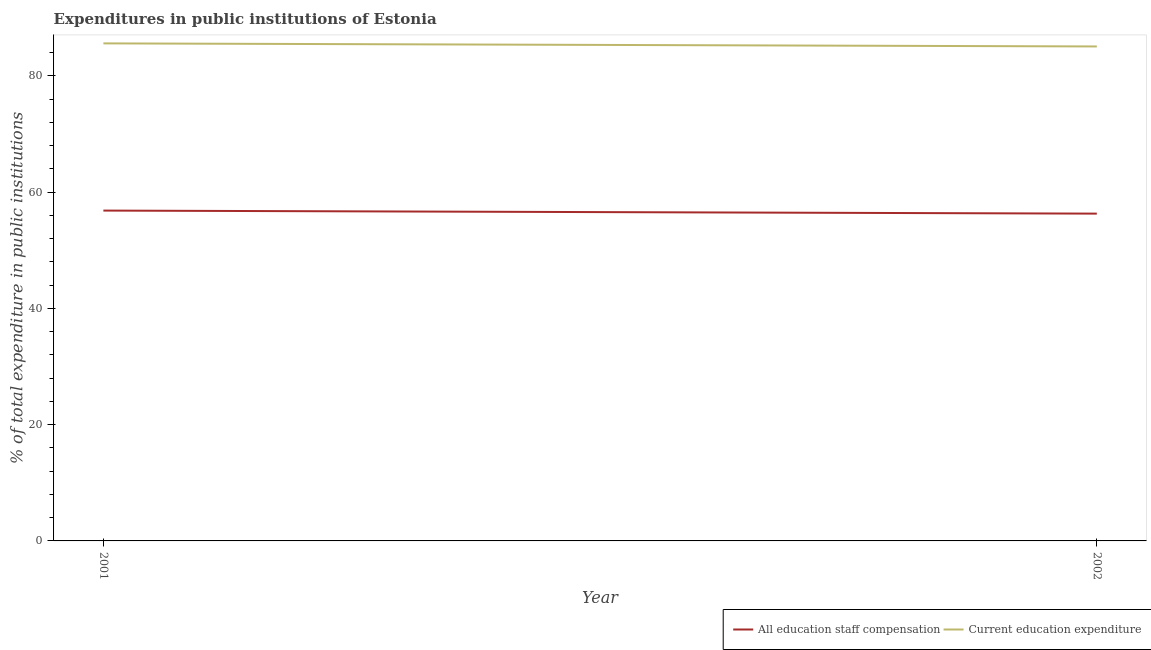Is the number of lines equal to the number of legend labels?
Offer a terse response. Yes. What is the expenditure in staff compensation in 2001?
Your answer should be very brief. 56.81. Across all years, what is the maximum expenditure in education?
Your answer should be compact. 85.57. Across all years, what is the minimum expenditure in education?
Ensure brevity in your answer.  85.04. In which year was the expenditure in education maximum?
Make the answer very short. 2001. In which year was the expenditure in education minimum?
Ensure brevity in your answer.  2002. What is the total expenditure in staff compensation in the graph?
Keep it short and to the point. 113.1. What is the difference between the expenditure in staff compensation in 2001 and that in 2002?
Provide a short and direct response. 0.53. What is the difference between the expenditure in education in 2002 and the expenditure in staff compensation in 2001?
Keep it short and to the point. 28.23. What is the average expenditure in staff compensation per year?
Your answer should be compact. 56.55. In the year 2001, what is the difference between the expenditure in education and expenditure in staff compensation?
Keep it short and to the point. 28.76. In how many years, is the expenditure in education greater than 8 %?
Provide a succinct answer. 2. What is the ratio of the expenditure in education in 2001 to that in 2002?
Offer a terse response. 1.01. Is the expenditure in education strictly greater than the expenditure in staff compensation over the years?
Your answer should be very brief. Yes. Are the values on the major ticks of Y-axis written in scientific E-notation?
Provide a succinct answer. No. Does the graph contain any zero values?
Keep it short and to the point. No. What is the title of the graph?
Offer a very short reply. Expenditures in public institutions of Estonia. Does "All education staff compensation" appear as one of the legend labels in the graph?
Offer a very short reply. Yes. What is the label or title of the X-axis?
Your answer should be compact. Year. What is the label or title of the Y-axis?
Ensure brevity in your answer.  % of total expenditure in public institutions. What is the % of total expenditure in public institutions of All education staff compensation in 2001?
Your answer should be very brief. 56.81. What is the % of total expenditure in public institutions of Current education expenditure in 2001?
Make the answer very short. 85.57. What is the % of total expenditure in public institutions of All education staff compensation in 2002?
Your answer should be compact. 56.29. What is the % of total expenditure in public institutions of Current education expenditure in 2002?
Give a very brief answer. 85.04. Across all years, what is the maximum % of total expenditure in public institutions of All education staff compensation?
Provide a short and direct response. 56.81. Across all years, what is the maximum % of total expenditure in public institutions of Current education expenditure?
Give a very brief answer. 85.57. Across all years, what is the minimum % of total expenditure in public institutions of All education staff compensation?
Your response must be concise. 56.29. Across all years, what is the minimum % of total expenditure in public institutions in Current education expenditure?
Give a very brief answer. 85.04. What is the total % of total expenditure in public institutions in All education staff compensation in the graph?
Your answer should be compact. 113.1. What is the total % of total expenditure in public institutions of Current education expenditure in the graph?
Offer a terse response. 170.61. What is the difference between the % of total expenditure in public institutions of All education staff compensation in 2001 and that in 2002?
Give a very brief answer. 0.53. What is the difference between the % of total expenditure in public institutions in Current education expenditure in 2001 and that in 2002?
Your answer should be very brief. 0.53. What is the difference between the % of total expenditure in public institutions in All education staff compensation in 2001 and the % of total expenditure in public institutions in Current education expenditure in 2002?
Your answer should be very brief. -28.23. What is the average % of total expenditure in public institutions in All education staff compensation per year?
Provide a succinct answer. 56.55. What is the average % of total expenditure in public institutions of Current education expenditure per year?
Your answer should be compact. 85.31. In the year 2001, what is the difference between the % of total expenditure in public institutions of All education staff compensation and % of total expenditure in public institutions of Current education expenditure?
Provide a succinct answer. -28.76. In the year 2002, what is the difference between the % of total expenditure in public institutions in All education staff compensation and % of total expenditure in public institutions in Current education expenditure?
Your answer should be compact. -28.75. What is the ratio of the % of total expenditure in public institutions in All education staff compensation in 2001 to that in 2002?
Offer a terse response. 1.01. What is the ratio of the % of total expenditure in public institutions of Current education expenditure in 2001 to that in 2002?
Ensure brevity in your answer.  1.01. What is the difference between the highest and the second highest % of total expenditure in public institutions in All education staff compensation?
Give a very brief answer. 0.53. What is the difference between the highest and the second highest % of total expenditure in public institutions of Current education expenditure?
Provide a short and direct response. 0.53. What is the difference between the highest and the lowest % of total expenditure in public institutions of All education staff compensation?
Your response must be concise. 0.53. What is the difference between the highest and the lowest % of total expenditure in public institutions of Current education expenditure?
Make the answer very short. 0.53. 